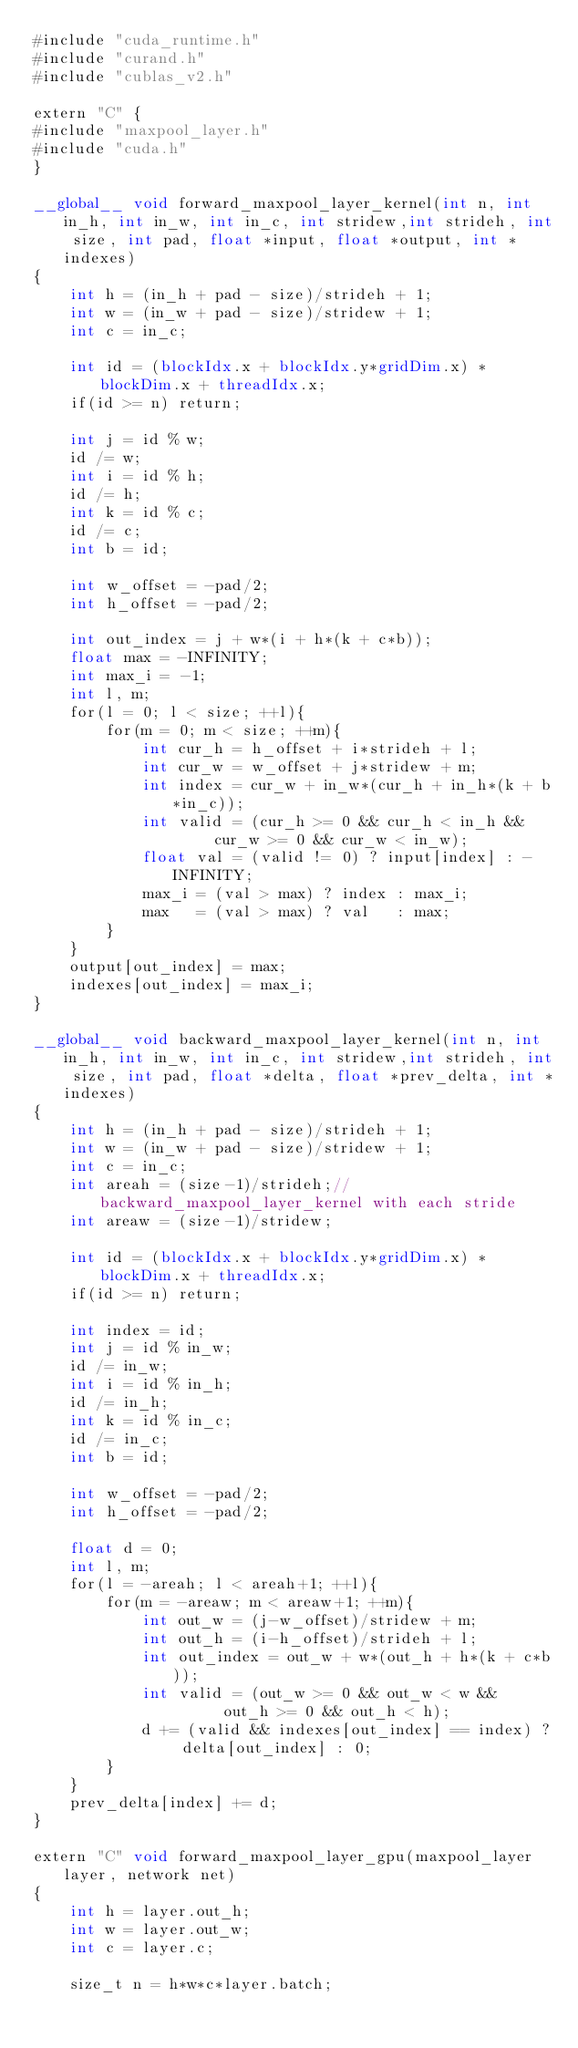Convert code to text. <code><loc_0><loc_0><loc_500><loc_500><_Cuda_>#include "cuda_runtime.h"
#include "curand.h"
#include "cublas_v2.h"

extern "C" {
#include "maxpool_layer.h"
#include "cuda.h"
}

__global__ void forward_maxpool_layer_kernel(int n, int in_h, int in_w, int in_c, int stridew,int strideh, int size, int pad, float *input, float *output, int *indexes)
{
    int h = (in_h + pad - size)/strideh + 1;
    int w = (in_w + pad - size)/stridew + 1;
    int c = in_c;

    int id = (blockIdx.x + blockIdx.y*gridDim.x) * blockDim.x + threadIdx.x;
    if(id >= n) return;

    int j = id % w;
    id /= w;
    int i = id % h;
    id /= h;
    int k = id % c;
    id /= c;
    int b = id;

    int w_offset = -pad/2;
    int h_offset = -pad/2;

    int out_index = j + w*(i + h*(k + c*b));
    float max = -INFINITY;
    int max_i = -1;
    int l, m;
    for(l = 0; l < size; ++l){
        for(m = 0; m < size; ++m){
            int cur_h = h_offset + i*strideh + l;
            int cur_w = w_offset + j*stridew + m;
            int index = cur_w + in_w*(cur_h + in_h*(k + b*in_c));
            int valid = (cur_h >= 0 && cur_h < in_h &&
                    cur_w >= 0 && cur_w < in_w);
            float val = (valid != 0) ? input[index] : -INFINITY;
            max_i = (val > max) ? index : max_i;
            max   = (val > max) ? val   : max;
        }
    }
    output[out_index] = max;
    indexes[out_index] = max_i;
}

__global__ void backward_maxpool_layer_kernel(int n, int in_h, int in_w, int in_c, int stridew,int strideh, int size, int pad, float *delta, float *prev_delta, int *indexes)
{
    int h = (in_h + pad - size)/strideh + 1;
    int w = (in_w + pad - size)/stridew + 1;
    int c = in_c;
    int areah = (size-1)/strideh;//backward_maxpool_layer_kernel with each stride
    int areaw = (size-1)/stridew;

    int id = (blockIdx.x + blockIdx.y*gridDim.x) * blockDim.x + threadIdx.x;
    if(id >= n) return;

    int index = id;
    int j = id % in_w;
    id /= in_w;
    int i = id % in_h;
    id /= in_h;
    int k = id % in_c;
    id /= in_c;
    int b = id;

    int w_offset = -pad/2;
    int h_offset = -pad/2;

    float d = 0;
    int l, m;
    for(l = -areah; l < areah+1; ++l){
        for(m = -areaw; m < areaw+1; ++m){
            int out_w = (j-w_offset)/stridew + m;
            int out_h = (i-h_offset)/strideh + l;
            int out_index = out_w + w*(out_h + h*(k + c*b));
            int valid = (out_w >= 0 && out_w < w &&
                     out_h >= 0 && out_h < h);
            d += (valid && indexes[out_index] == index) ? delta[out_index] : 0;
        }
    }
    prev_delta[index] += d;
}

extern "C" void forward_maxpool_layer_gpu(maxpool_layer layer, network net)
{
    int h = layer.out_h;
    int w = layer.out_w;
    int c = layer.c;

    size_t n = h*w*c*layer.batch;
</code> 